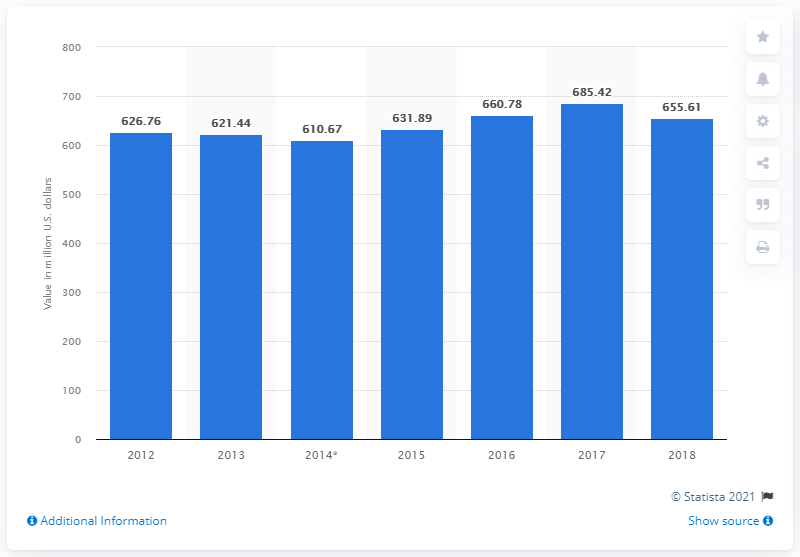Could you tell me more about the significance of cocoa exports for Mexico's economy? Certainly! Cocoa is a crucial agricultural product for Mexico with a rich cultural heritage reaching back to the Aztecs and Mayans. As a cash crop, it plays a significant role in the agricultural sector, providing income for farmers and contributing to the country's GDP. The fluctuations in exports are indicative of market demand, pricing, domestic production levels, and international trade policies affecting Mexico's economy. 